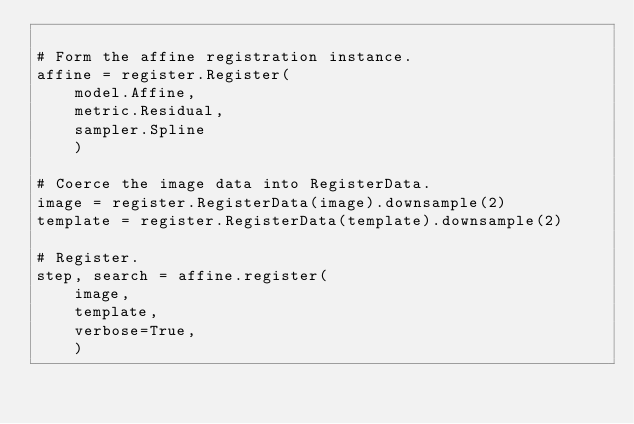<code> <loc_0><loc_0><loc_500><loc_500><_Python_>
# Form the affine registration instance.
affine = register.Register(
    model.Affine,
    metric.Residual,
    sampler.Spline
    )

# Coerce the image data into RegisterData.
image = register.RegisterData(image).downsample(2)
template = register.RegisterData(template).downsample(2)

# Register.
step, search = affine.register(
    image,
    template,
    verbose=True,
    )
</code> 